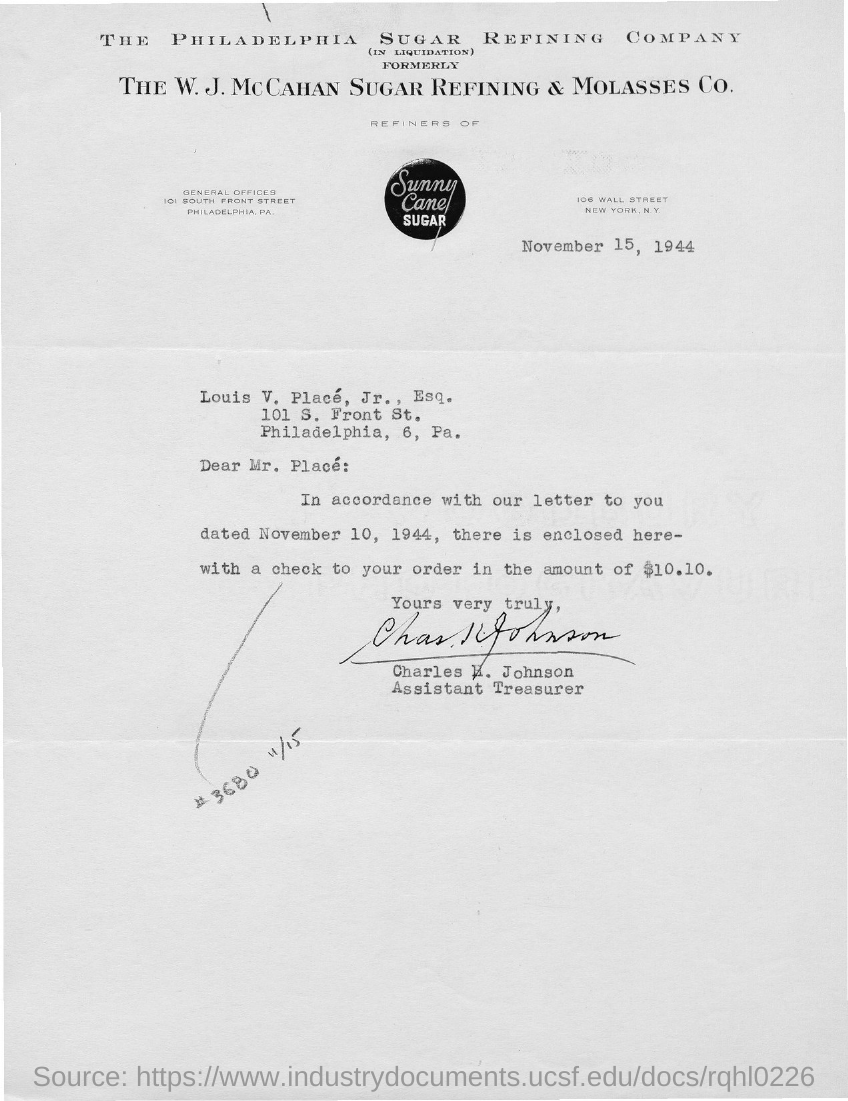What is the date of the letter?
Keep it short and to the point. November 15, 1944. What is written on the circular image?
Your answer should be very brief. Sunny Cane Sugar. What is the designation of Charles E. Johnson?
Offer a terse response. Assistant Treasurer. How much is the check amount?
Offer a very short reply. $10.10. 